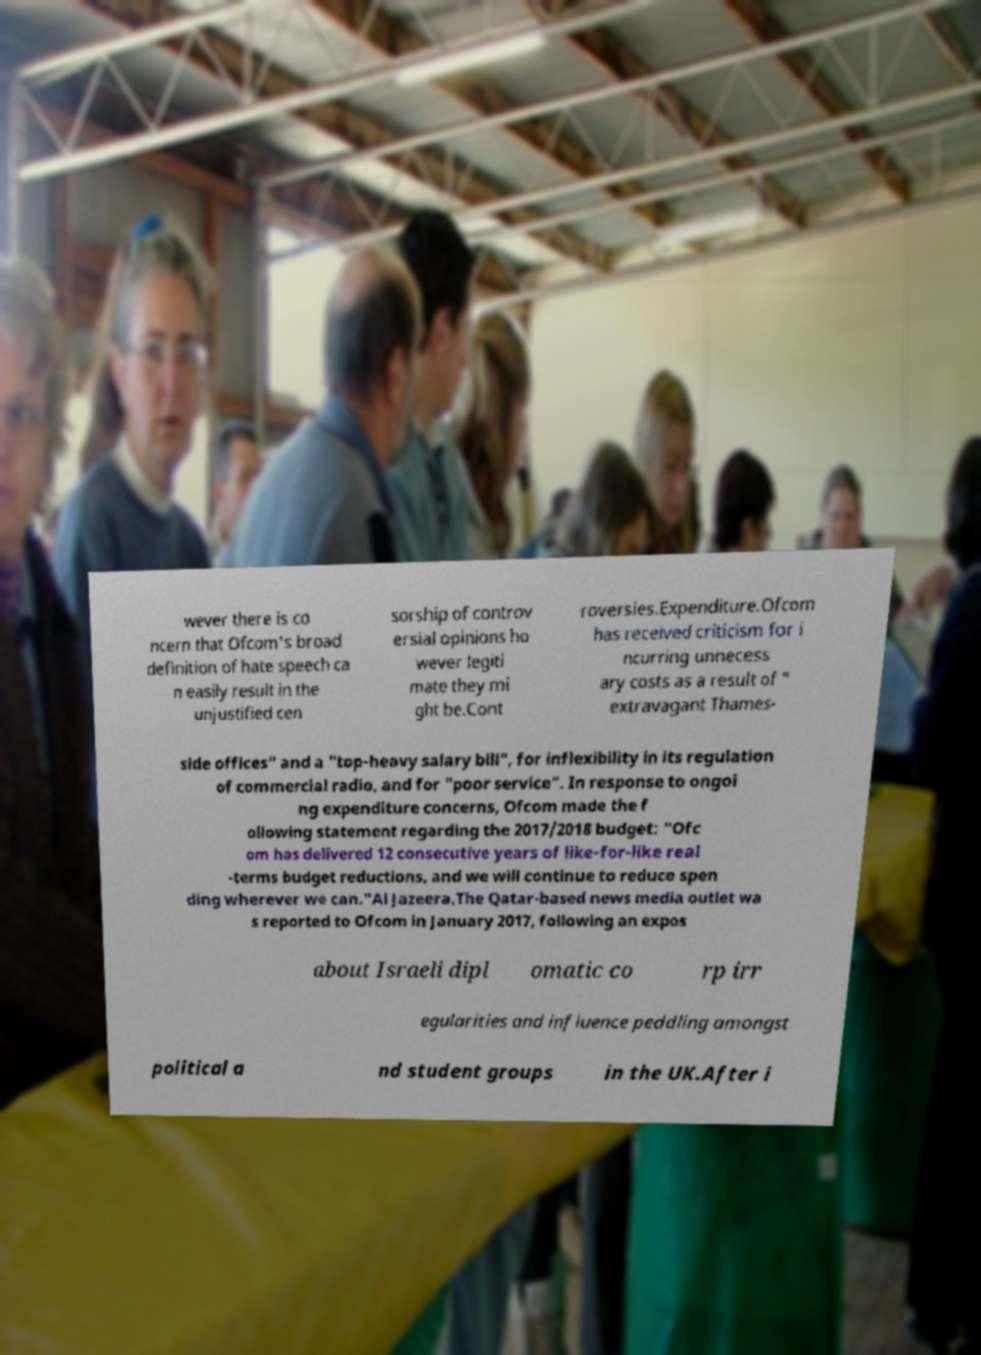I need the written content from this picture converted into text. Can you do that? wever there is co ncern that Ofcom's broad definition of hate speech ca n easily result in the unjustified cen sorship of controv ersial opinions ho wever legiti mate they mi ght be.Cont roversies.Expenditure.Ofcom has received criticism for i ncurring unnecess ary costs as a result of " extravagant Thames- side offices" and a "top-heavy salary bill", for inflexibility in its regulation of commercial radio, and for "poor service". In response to ongoi ng expenditure concerns, Ofcom made the f ollowing statement regarding the 2017/2018 budget: "Ofc om has delivered 12 consecutive years of like-for-like real -terms budget reductions, and we will continue to reduce spen ding wherever we can."Al Jazeera.The Qatar-based news media outlet wa s reported to Ofcom in January 2017, following an expos about Israeli dipl omatic co rp irr egularities and influence peddling amongst political a nd student groups in the UK.After i 